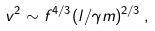<formula> <loc_0><loc_0><loc_500><loc_500>v ^ { 2 } \sim f ^ { 4 / 3 } ( l / \gamma m ) ^ { 2 / 3 } \, ,</formula> 